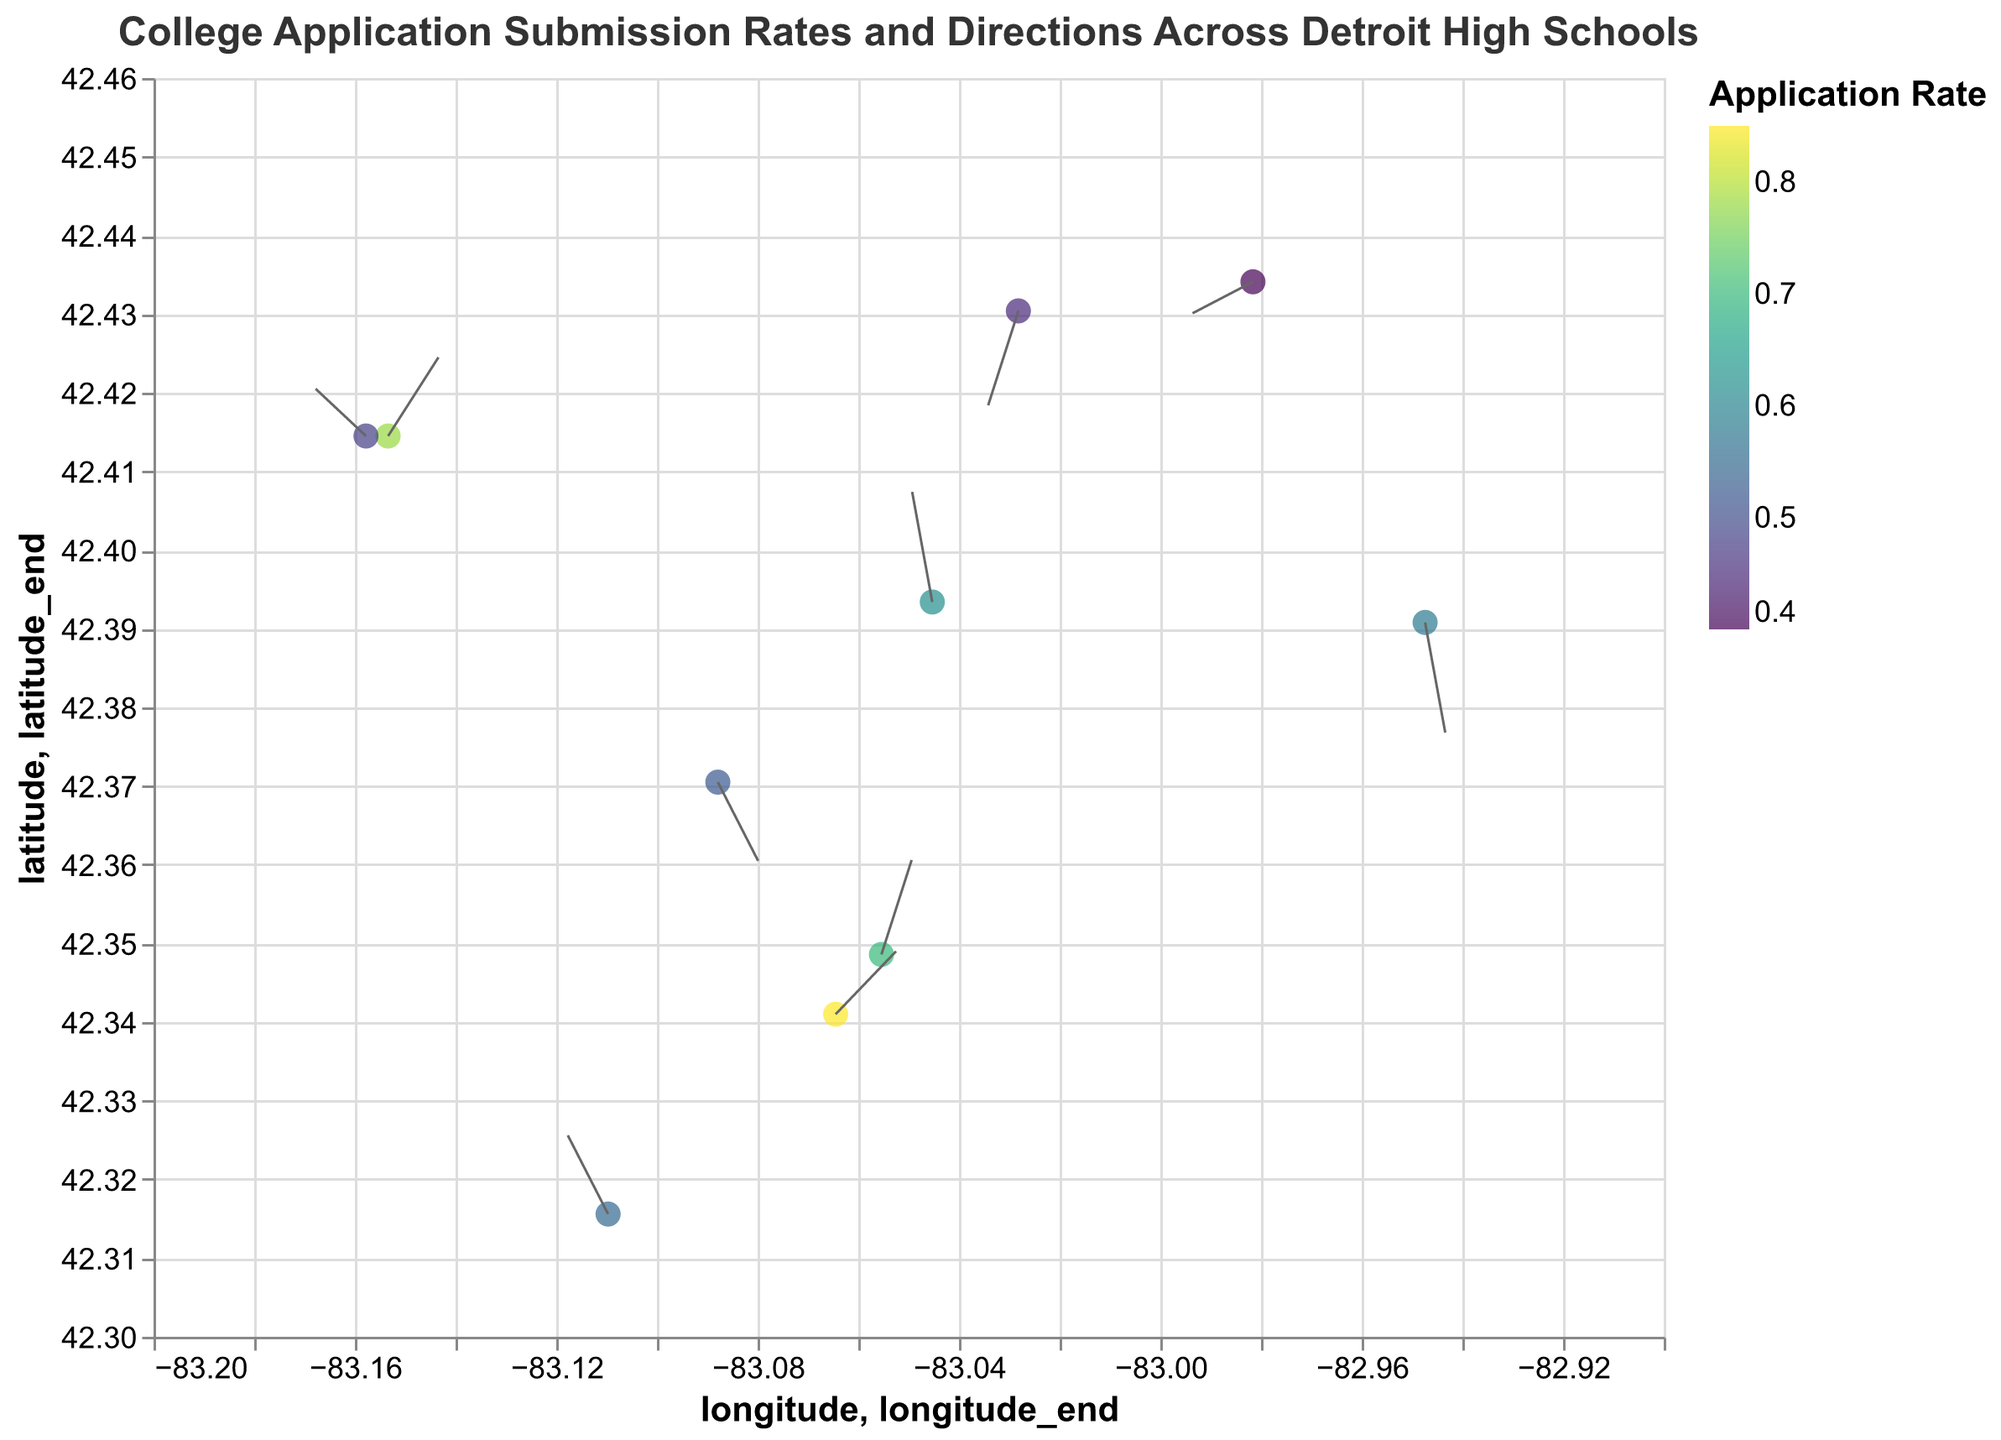What is the title of the figure? The title is usually displayed at the top of a figure and describes what the figure is about. In this case, the title is clearly stated in the data provided.
Answer: College Application Submission Rates and Directions Across Detroit High Schools How many high schools are represented in the figure? Count the number of data points representing different high schools. Each data point corresponds to a high school.
Answer: 10 Which high school has the highest college application submission rate? Look for the high school that has the highest value in the "application_rate" field. The color on the plot corresponding to a higher application rate would typically be more intense.
Answer: Cass Technical High School What is the latitude and longitude of the Renaissance High School? Find the data point corresponding to Renaissance High School and check its latitude and longitude values.
Answer: Latitude: 42.4145, Longitude: -83.1534 Which high school is located the farthest east? Compare the longitude values of all the high schools and identify the school with the smallest longitude value, meaning it will be the farthest east.
Answer: East English Village Preparatory Academy Which school has a decreasing direction in its college application submission trends? Look for the schools where the direction_x and direction_y values would indicate a decreasing trend by being negative.
Answer: Osborn High School, Pershing High School Which high school has the smallest college application submission rate and what direction does it point to? Identify the school with the lowest application_rate and then check the direction_x and direction_y values for that school.
Answer: Osborn High School, Points to (-0.6, -0.2) What is the average college application submission rate across all the high schools? Sum up all the application_rate values and then divide by the number of high schools (10 in this case).
Answer: (0.85 + 0.78 + 0.62 + 0.7 + 0.55 + 0.48 + 0.58 + 0.4 + 0.45 + 0.52) / 10 = 5.93 / 10 = 0.593 Which high school points the steepest upward direction in its application submission trends? Look for the high school with the largest positive value in the direction_y field.
Answer: Martin Luther King Jr. Senior High School What is the general trend direction for Detroit School of Arts, and how does it relate to its submission rate? Look at the direction_x and direction_y values for Detroit School of Arts to understand the trend direction. Compare its application rate with others to see if it is high or low.
Answer: Detroit School of Arts: (0.3, 0.6) - General upward trend, High submission rate (0.70) Which schools have a downward trend in their application submission? Identify the schools with negative direction_y values.
Answer: East English Village Preparatory Academy, Osborn High School, Pershing High School, Central High School 